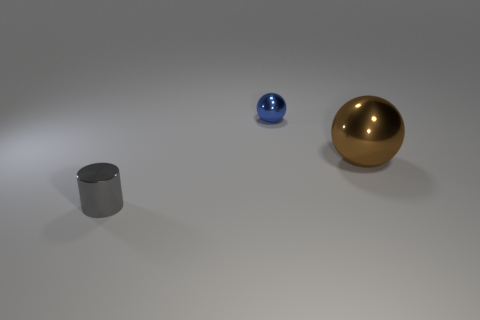What size is the object left of the tiny blue ball?
Provide a succinct answer. Small. What number of other things are there of the same material as the gray thing
Give a very brief answer. 2. Is the number of tiny blue spheres greater than the number of small yellow rubber cylinders?
Provide a short and direct response. Yes. What is the color of the tiny sphere?
Provide a succinct answer. Blue. There is a tiny metallic thing that is right of the gray cylinder; are there any small metal things that are left of it?
Keep it short and to the point. Yes. There is a metal thing that is on the right side of the small object that is behind the small metallic cylinder; what is its shape?
Ensure brevity in your answer.  Sphere. Is the number of metal balls less than the number of brown objects?
Give a very brief answer. No. Is the small blue object made of the same material as the small cylinder?
Your answer should be very brief. Yes. What is the color of the thing that is both right of the small metal cylinder and to the left of the big shiny thing?
Offer a very short reply. Blue. Are there any blue balls of the same size as the gray thing?
Provide a succinct answer. Yes. 